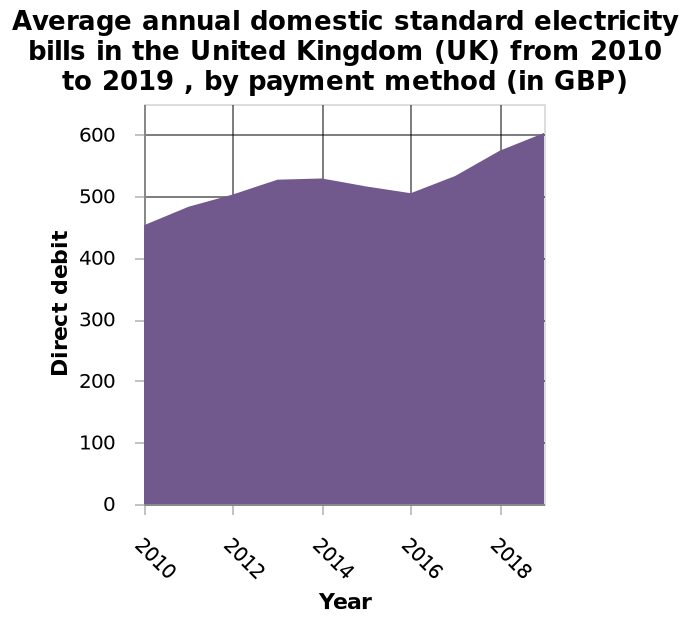<image>
please summary the statistics and relations of the chart There was a dip in prices in 2016. Electricity bills have increased in price since 2010-2019. What is defined along the y-axis? Direct debit. Offer a thorough analysis of the image. From 2010 to 2018 the average standard electricity bill rose. Have electricity bills been increasing in price since 2010-2019?  Yes, electricity bills have been increasing in price since 2010-2019. 